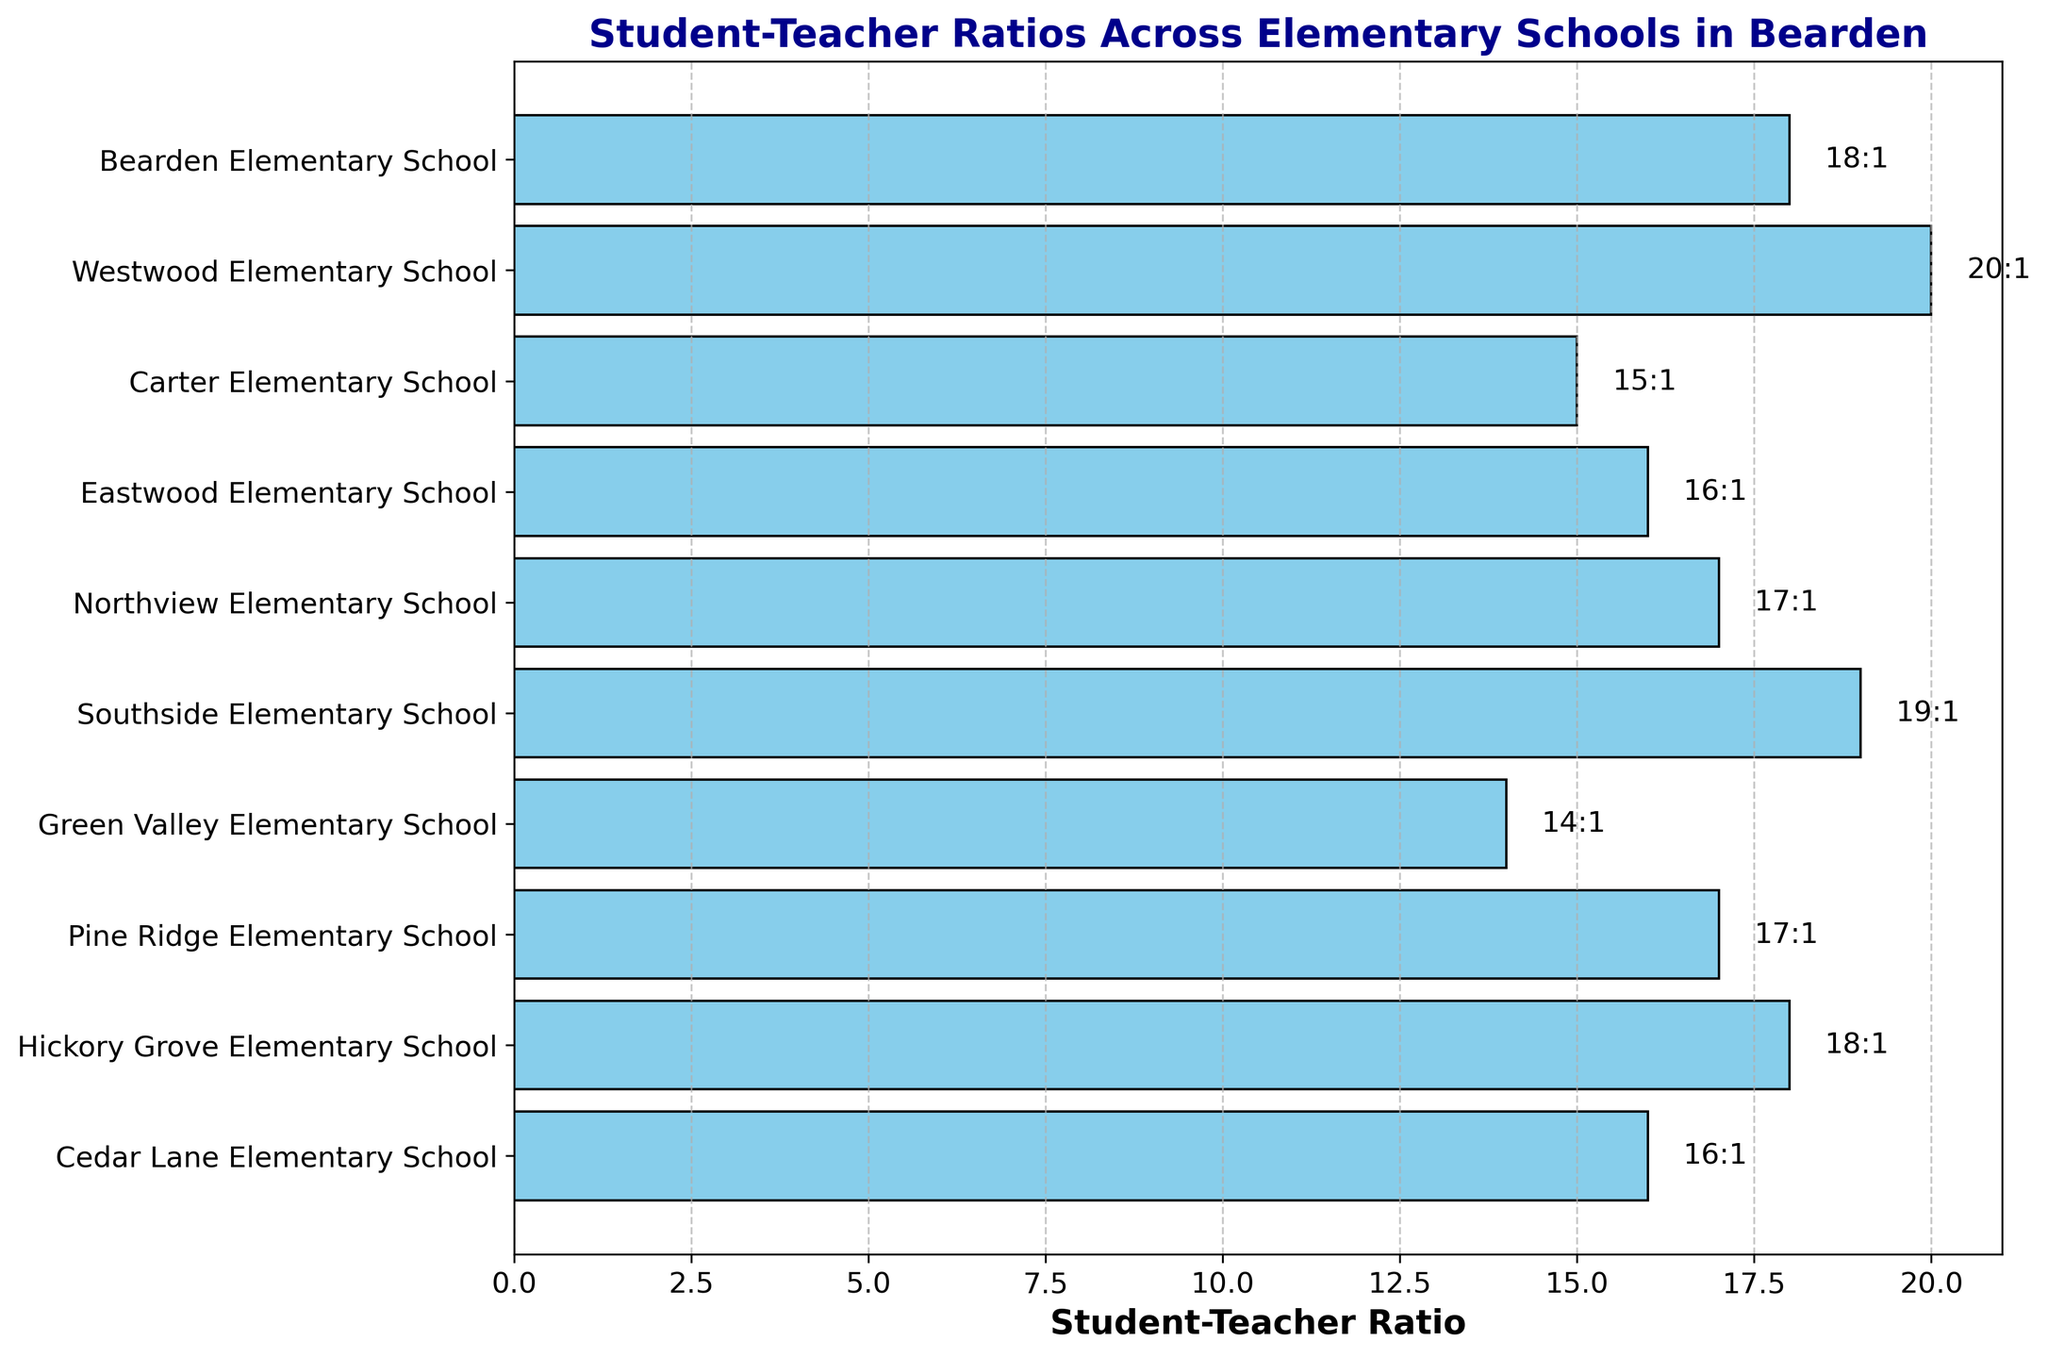Which school has the highest student-teacher ratio? The highest bar represents the school with the highest student-teacher ratio. The bar for Westwood Elementary School is the longest, indicating that it has the highest ratio.
Answer: Westwood Elementary School Which school has the lowest student-teacher ratio? The shortest bar represents the school with the lowest student-teacher ratio. The bar for Green Valley Elementary School is the shortest, indicating the lowest ratio.
Answer: Green Valley Elementary School What is the combined student-teacher ratio for Northview and Cedar Lane Elementary Schools? The student-teacher ratios for Northview Elementary School and Cedar Lane Elementary School are 17:1 and 16:1, respectively. Adding these together: 17 + 16 = 33.
Answer: 33 How many schools have a student-teacher ratio of 17:1? By visually inspecting the bars and their annotations, we can see that Northview Elementary School and Pine Ridge Elementary School both have a ratio of 17:1.
Answer: 2 Which schools have a higher student-teacher ratio than Northview Elementary School? Any bar longer than the bar for Northview Elementary School (17:1) indicates a higher ratio. Westwood Elementary School (20:1) and Southside Elementary School (19:1) have higher ratios.
Answer: Westwood Elementary School, Southside Elementary School What is the difference in student-teacher ratios between Bearden Elementary School and Carter Elementary School? The student-teacher ratio for Bearden Elementary School is 18:1, and for Carter Elementary School, it is 15:1. Subtracting these values: 18 - 15 = 3.
Answer: 3 What is the average student-teacher ratio among all schools? Adding the ratios for all the schools and then dividing by the number of schools: (18 + 20 + 15 + 16 + 17 + 19 + 14 + 17 + 18 + 16) / 10 = 170 / 10 = 17.
Answer: 17 Are there more schools with a student-teacher ratio of 16:1 or 18:1? By counting the bars with annotations 16:1 and 18:1, there are two schools for each ratio.
Answer: Equal What is the visual feature used to represent the student-teacher ratios in the chart? The chart uses horizontal bars to represent the student-teacher ratios, with the length of each bar corresponding to the ratio value.
Answer: Horizontal bars How many schools have a student-teacher ratio less than 18:1? By visually inspecting the bars below the 18:1 mark, there are six schools (Carter, Eastwood, Northview, Green Valley, Pine Ridge, Cedar Lane).
Answer: 6 